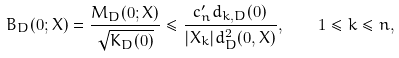Convert formula to latex. <formula><loc_0><loc_0><loc_500><loc_500>B _ { D } ( 0 ; X ) = \frac { M _ { D } ( 0 ; X ) } { \sqrt { K _ { D } ( 0 ) } } \leq \frac { c ^ { \prime } _ { n } d _ { k , D } ( 0 ) } { | X _ { k } | d _ { D } ^ { 2 } ( 0 , X ) } , \quad 1 \leq k \leq n ,</formula> 